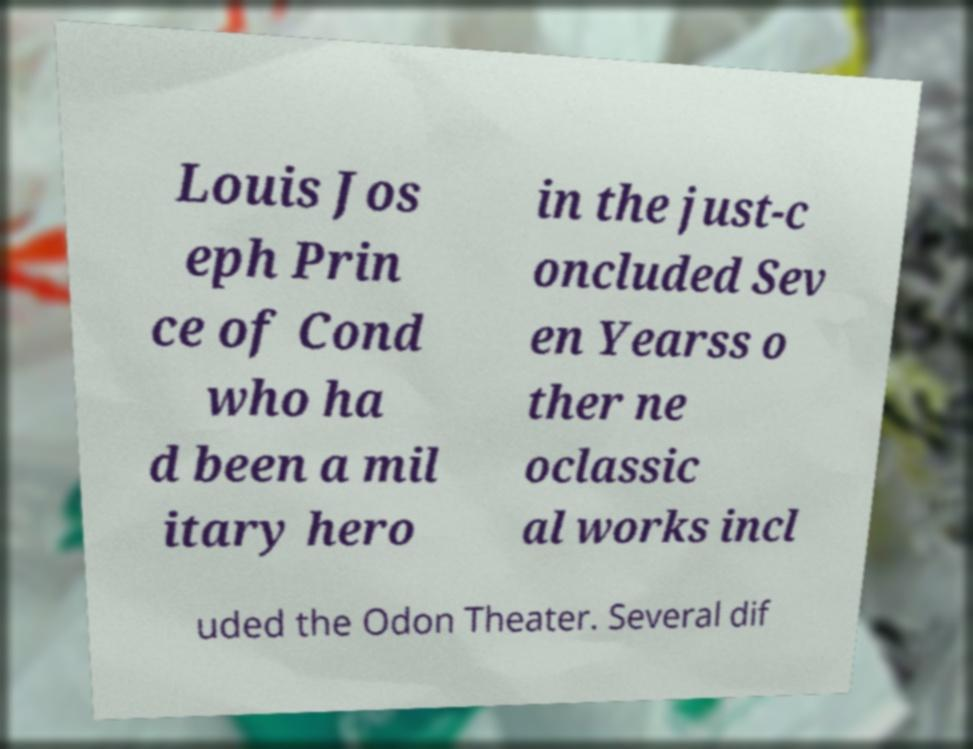For documentation purposes, I need the text within this image transcribed. Could you provide that? Louis Jos eph Prin ce of Cond who ha d been a mil itary hero in the just-c oncluded Sev en Yearss o ther ne oclassic al works incl uded the Odon Theater. Several dif 